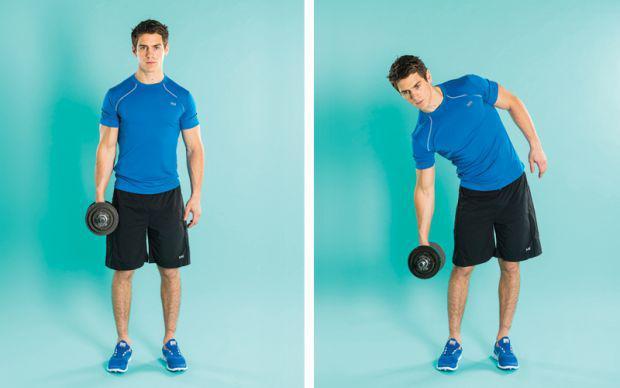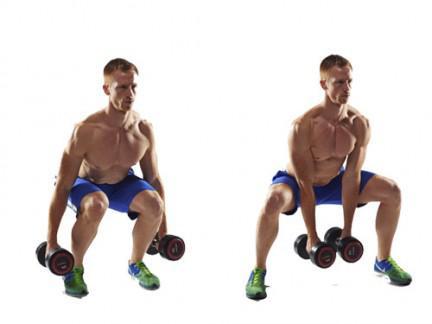The first image is the image on the left, the second image is the image on the right. For the images shown, is this caption "An image shows a workout sequence featuring a man in blue shorts with dumbbells in each hand." true? Answer yes or no. Yes. The first image is the image on the left, the second image is the image on the right. Assess this claim about the two images: "One image shows a man in a blue shirt doing exercises with weights, while the other image shows a shirtless man in blue shorts doing exercises with weights". Correct or not? Answer yes or no. Yes. 